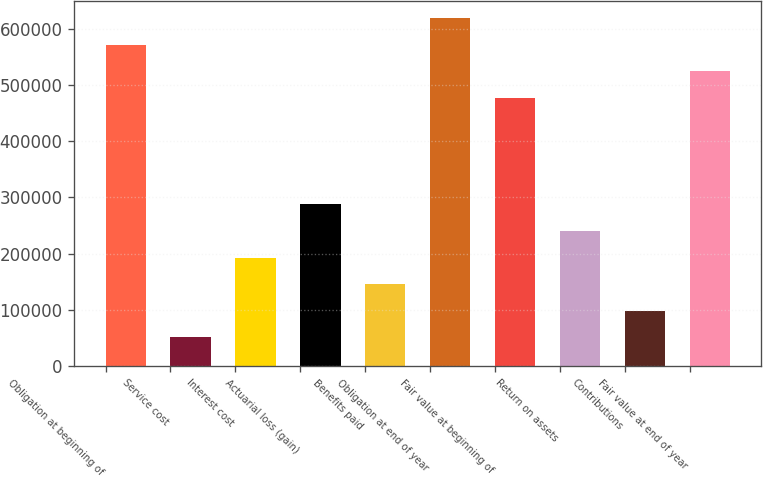Convert chart. <chart><loc_0><loc_0><loc_500><loc_500><bar_chart><fcel>Obligation at beginning of<fcel>Service cost<fcel>Interest cost<fcel>Actuarial loss (gain)<fcel>Benefits paid<fcel>Obligation at end of year<fcel>Fair value at beginning of<fcel>Return on assets<fcel>Contributions<fcel>Fair value at end of year<nl><fcel>572239<fcel>50768.4<fcel>192988<fcel>287800<fcel>145581<fcel>619645<fcel>477426<fcel>240394<fcel>98174.8<fcel>524832<nl></chart> 